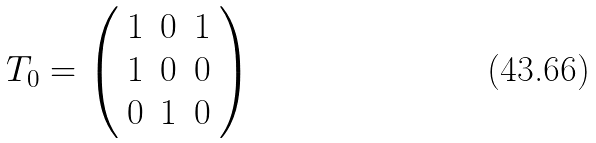Convert formula to latex. <formula><loc_0><loc_0><loc_500><loc_500>T _ { 0 } = \left ( \begin{array} { c c c } 1 & 0 & 1 \\ 1 & 0 & 0 \\ 0 & 1 & 0 \end{array} \right )</formula> 